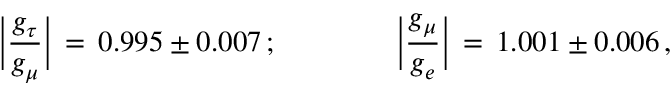<formula> <loc_0><loc_0><loc_500><loc_500>\left | { \frac { g _ { \tau } } { g _ { \mu } } } \right | \, = \, 0 . 9 9 5 \pm 0 . 0 0 7 \, ; \quad \left | { \frac { g _ { \mu } } { g _ { e } } } \right | \, = \, 1 . 0 0 1 \pm 0 . 0 0 6 \, ,</formula> 